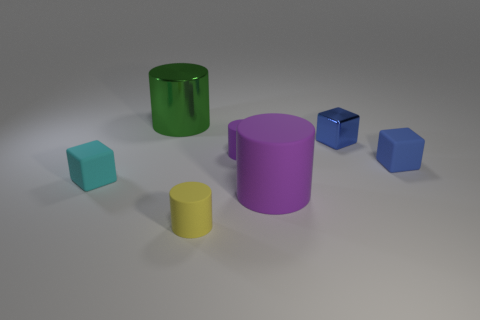How many other objects are there of the same shape as the cyan object?
Give a very brief answer. 2. Does the tiny yellow cylinder have the same material as the big green cylinder?
Provide a short and direct response. No. The small block that is both in front of the small metallic cube and on the right side of the big purple cylinder is made of what material?
Keep it short and to the point. Rubber. The metallic thing to the right of the yellow object is what color?
Give a very brief answer. Blue. Are there more green metal cylinders on the right side of the cyan thing than small gray rubber blocks?
Offer a terse response. Yes. How many other things are there of the same size as the cyan thing?
Keep it short and to the point. 4. What number of blue matte cubes are in front of the big matte object?
Give a very brief answer. 0. Are there the same number of big rubber cylinders that are left of the small cyan matte block and matte cylinders to the right of the green thing?
Offer a very short reply. No. There is a yellow matte object that is the same shape as the large shiny thing; what size is it?
Offer a very short reply. Small. The object that is in front of the large purple matte cylinder has what shape?
Provide a succinct answer. Cylinder. 